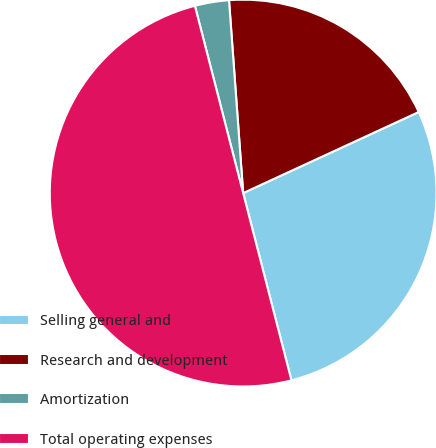<chart> <loc_0><loc_0><loc_500><loc_500><pie_chart><fcel>Selling general and<fcel>Research and development<fcel>Amortization<fcel>Total operating expenses<nl><fcel>27.87%<fcel>19.28%<fcel>2.85%<fcel>50.0%<nl></chart> 